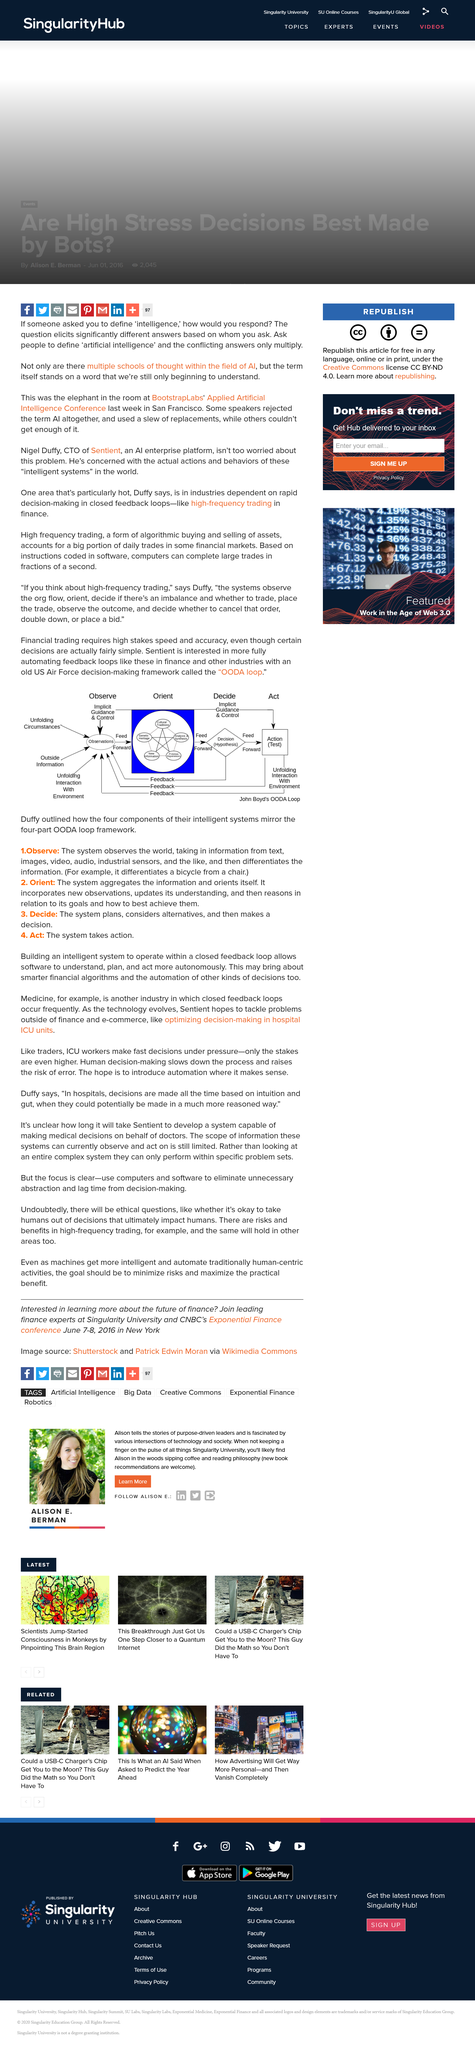Identify some key points in this picture. Our computer can process large amounts of trades at speeds of fractions of a second, making it ideal for fast-paced financial environments. Observe, Orient, Decide, and Act" is an acronym that is commonly used to describe the OODA loop, a decision-making framework that involves rapidly cycling through these four stages to respond to changing circumstances in a timely and effective manner. Financial trading requires high stakes speed and accuracy, even when the decision is fairly simple. 